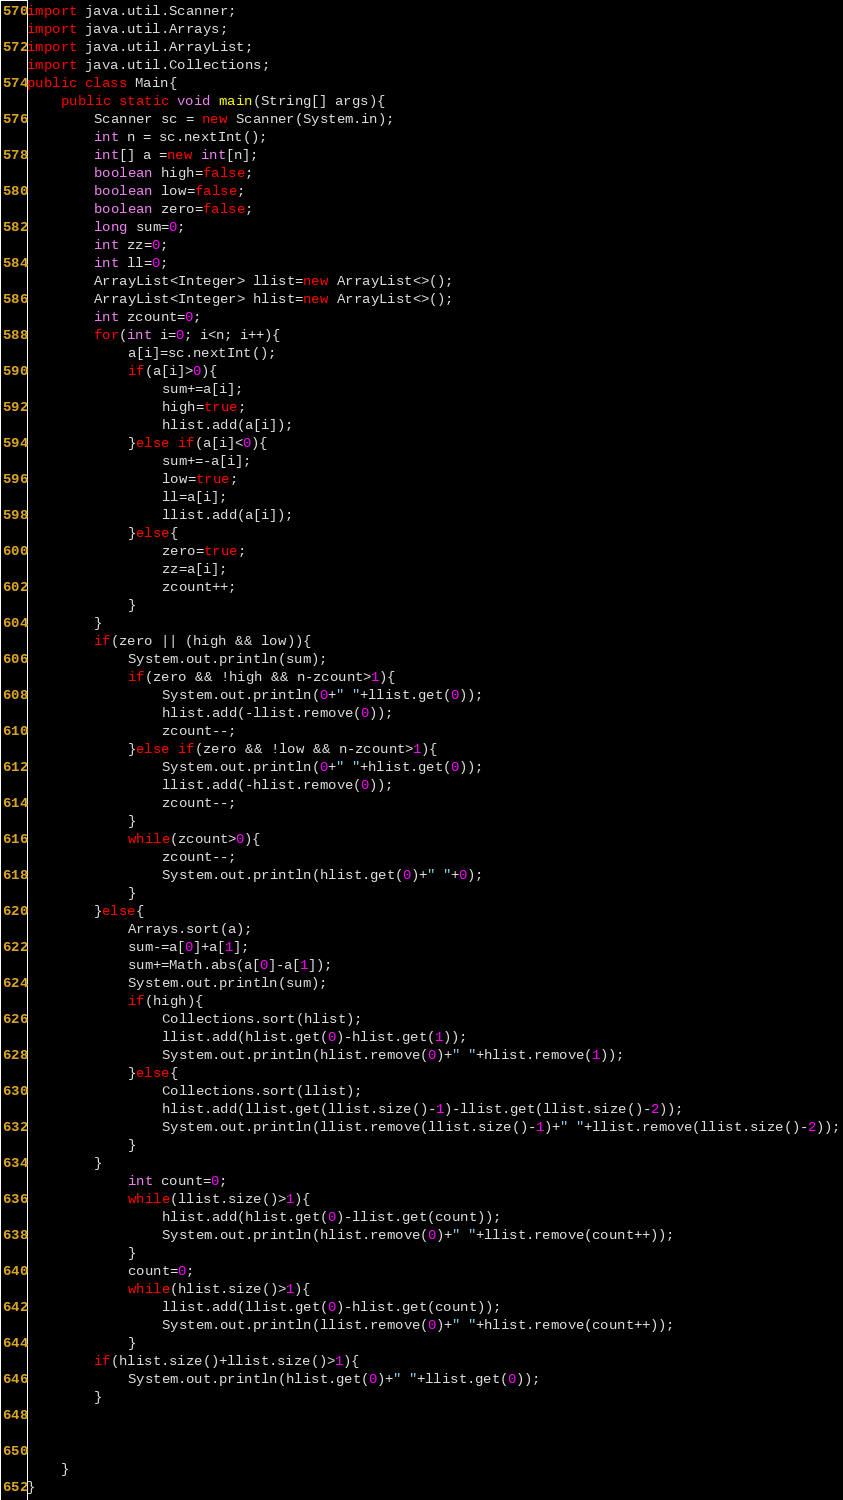Convert code to text. <code><loc_0><loc_0><loc_500><loc_500><_Java_>import java.util.Scanner;
import java.util.Arrays;
import java.util.ArrayList;
import java.util.Collections;
public class Main{
	public static void main(String[] args){
		Scanner sc = new Scanner(System.in);
		int n = sc.nextInt();
		int[] a =new int[n];
		boolean high=false;
		boolean low=false;
		boolean zero=false;
		long sum=0;
		int zz=0;
		int ll=0;
		ArrayList<Integer> llist=new ArrayList<>();
		ArrayList<Integer> hlist=new ArrayList<>();
		int zcount=0;
		for(int i=0; i<n; i++){
			a[i]=sc.nextInt();
			if(a[i]>0){
				sum+=a[i];
				high=true;
				hlist.add(a[i]);
			}else if(a[i]<0){
				sum+=-a[i];
				low=true;
				ll=a[i];
				llist.add(a[i]);
			}else{
				zero=true;
				zz=a[i];
				zcount++;
			}
		}
		if(zero || (high && low)){
			System.out.println(sum);
			if(zero && !high && n-zcount>1){
				System.out.println(0+" "+llist.get(0));
				hlist.add(-llist.remove(0));
				zcount--;
			}else if(zero && !low && n-zcount>1){
				System.out.println(0+" "+hlist.get(0));
				llist.add(-hlist.remove(0));
				zcount--;
			}
			while(zcount>0){
				zcount--;
				System.out.println(hlist.get(0)+" "+0);
			}
		}else{
			Arrays.sort(a);
			sum-=a[0]+a[1];
			sum+=Math.abs(a[0]-a[1]);
			System.out.println(sum);
			if(high){
				Collections.sort(hlist);
				llist.add(hlist.get(0)-hlist.get(1));
				System.out.println(hlist.remove(0)+" "+hlist.remove(1));
			}else{
				Collections.sort(llist);
				hlist.add(llist.get(llist.size()-1)-llist.get(llist.size()-2));
				System.out.println(llist.remove(llist.size()-1)+" "+llist.remove(llist.size()-2));
			}
		}
			int count=0;
			while(llist.size()>1){
				hlist.add(hlist.get(0)-llist.get(count));
				System.out.println(hlist.remove(0)+" "+llist.remove(count++));
			}
			count=0;
			while(hlist.size()>1){
				llist.add(llist.get(0)-hlist.get(count));
				System.out.println(llist.remove(0)+" "+hlist.remove(count++));
			}
		if(hlist.size()+llist.size()>1){
			System.out.println(hlist.get(0)+" "+llist.get(0));
		}
			
		
		
	}
}
</code> 